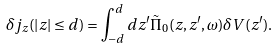Convert formula to latex. <formula><loc_0><loc_0><loc_500><loc_500>\delta j _ { z } ( | z | \leq d ) = \int _ { - d } ^ { d } d z ^ { \prime } \tilde { \Pi } _ { 0 } ( z , z ^ { \prime } , \omega ) \delta V ( z ^ { \prime } ) .</formula> 